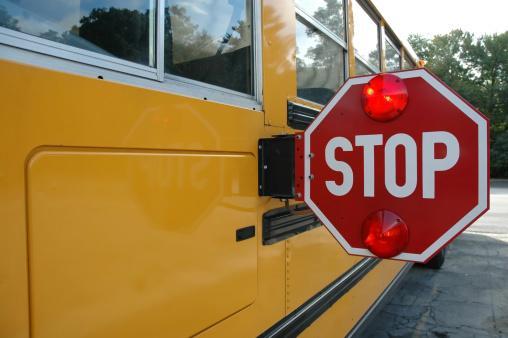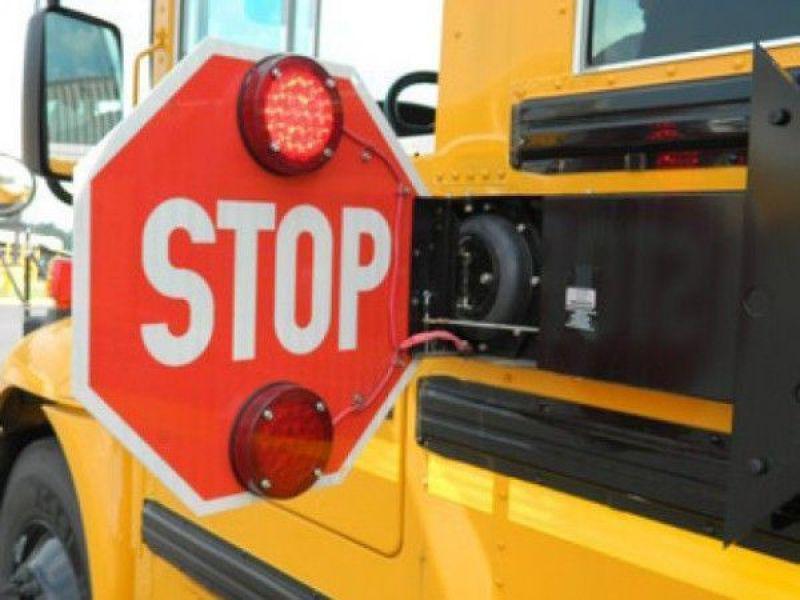The first image is the image on the left, the second image is the image on the right. Given the left and right images, does the statement "Exactly two stop signs are extended." hold true? Answer yes or no. Yes. The first image is the image on the left, the second image is the image on the right. For the images displayed, is the sentence "Each image includes a red octagonal sign with a word between two red lights on the top and bottom, and in one image, the top light appears illuminated." factually correct? Answer yes or no. Yes. 